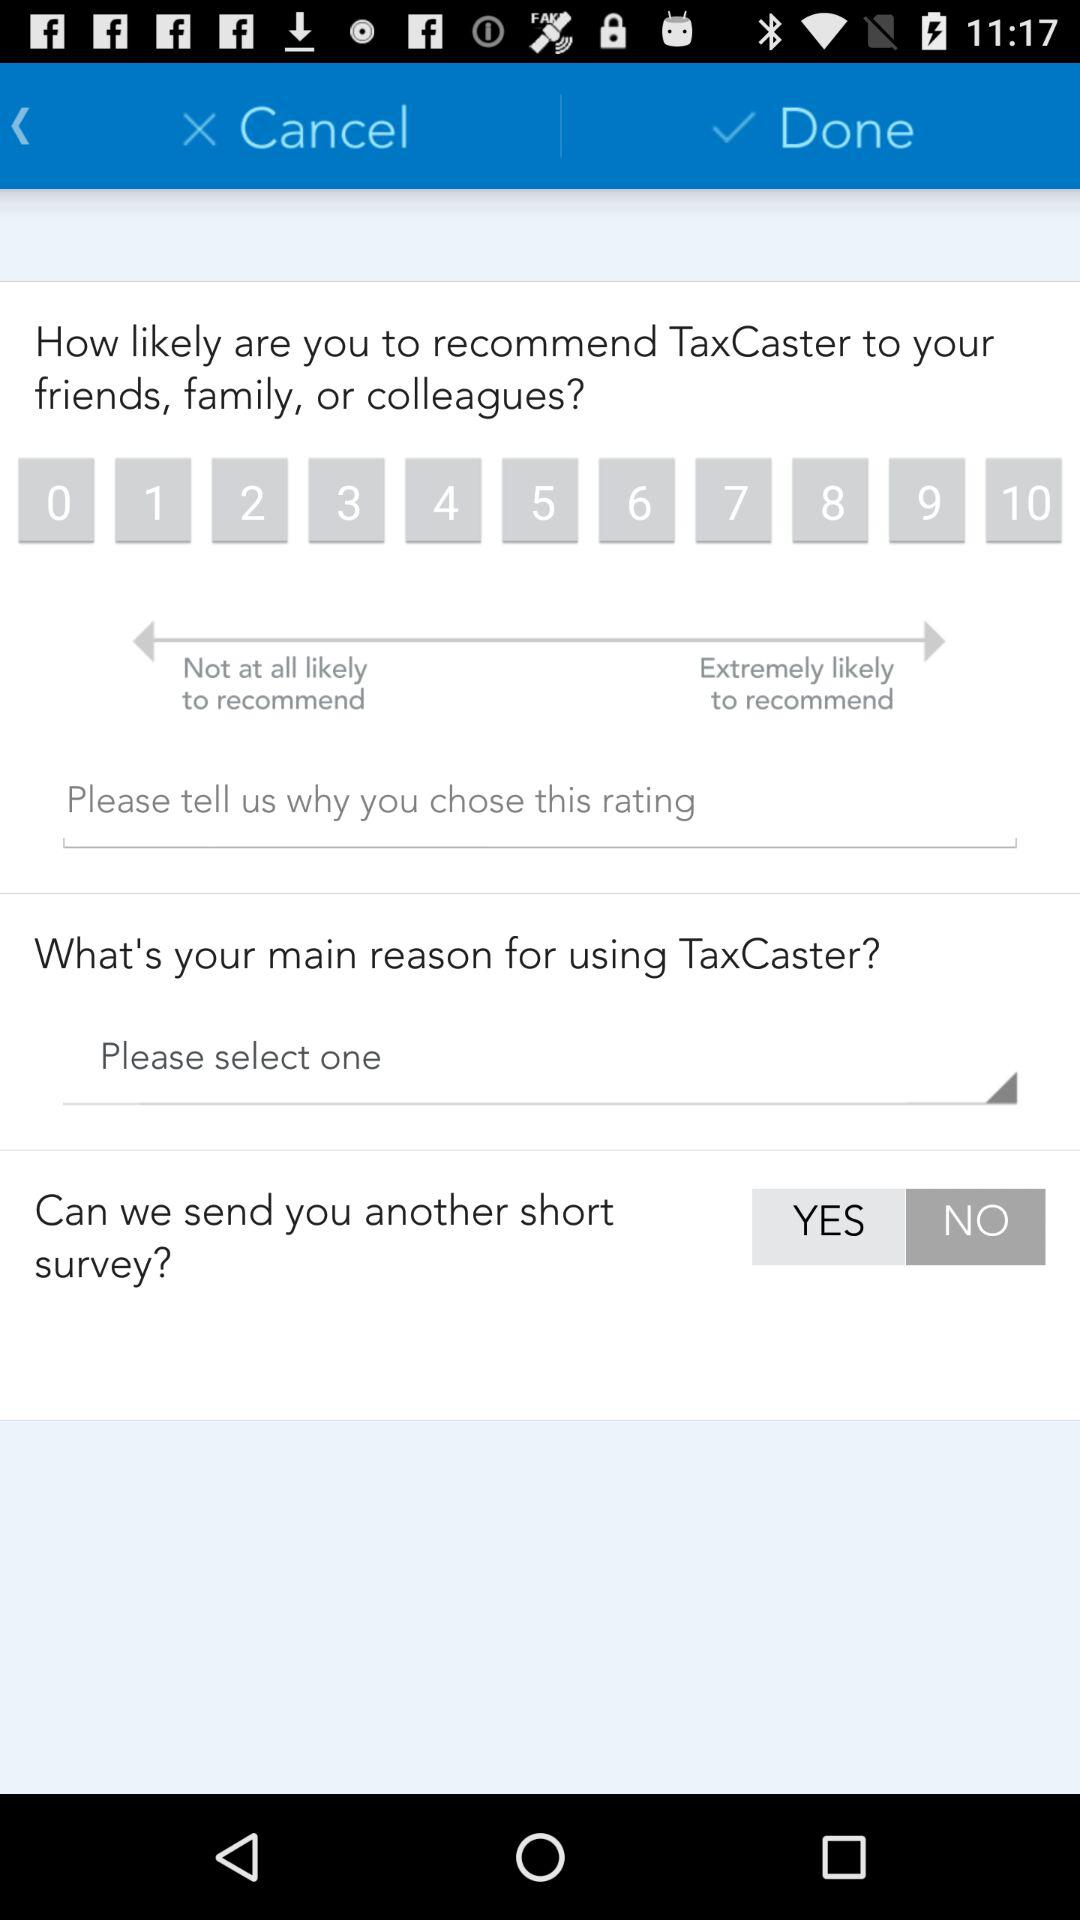What is the name of the application? The name of the application is "TaxCaster". 